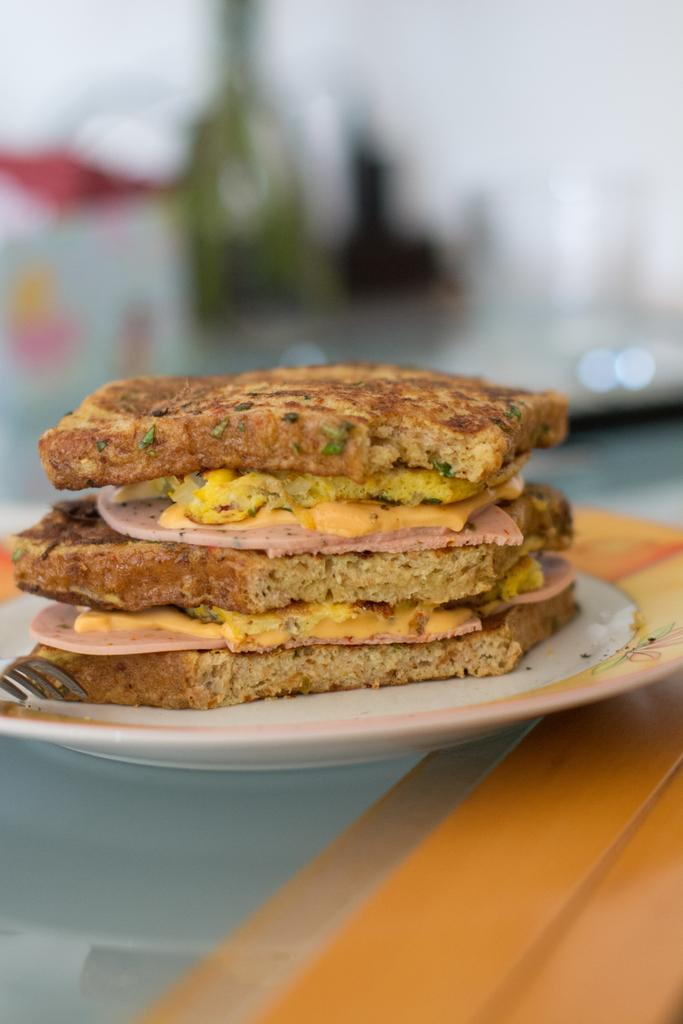What type of objects can be seen in the image? There are food items and a fork on a plate in the image. Can you describe the arrangement of the objects? The fork is on a plate, and the plate is on an object. What can be observed about the background of the image? The background of the image is blurred. What type of writing can be seen on the plate in the image? There is no writing visible on the plate in the image. Is there a minister present in the image? There is no minister present in the image. 